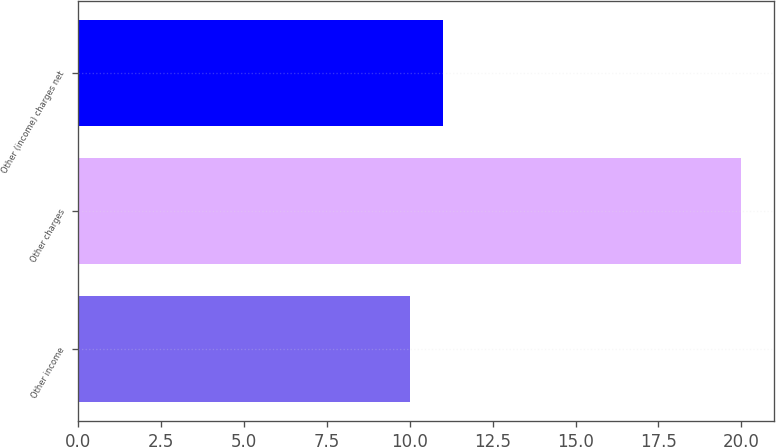Convert chart. <chart><loc_0><loc_0><loc_500><loc_500><bar_chart><fcel>Other income<fcel>Other charges<fcel>Other (income) charges net<nl><fcel>10<fcel>20<fcel>11<nl></chart> 